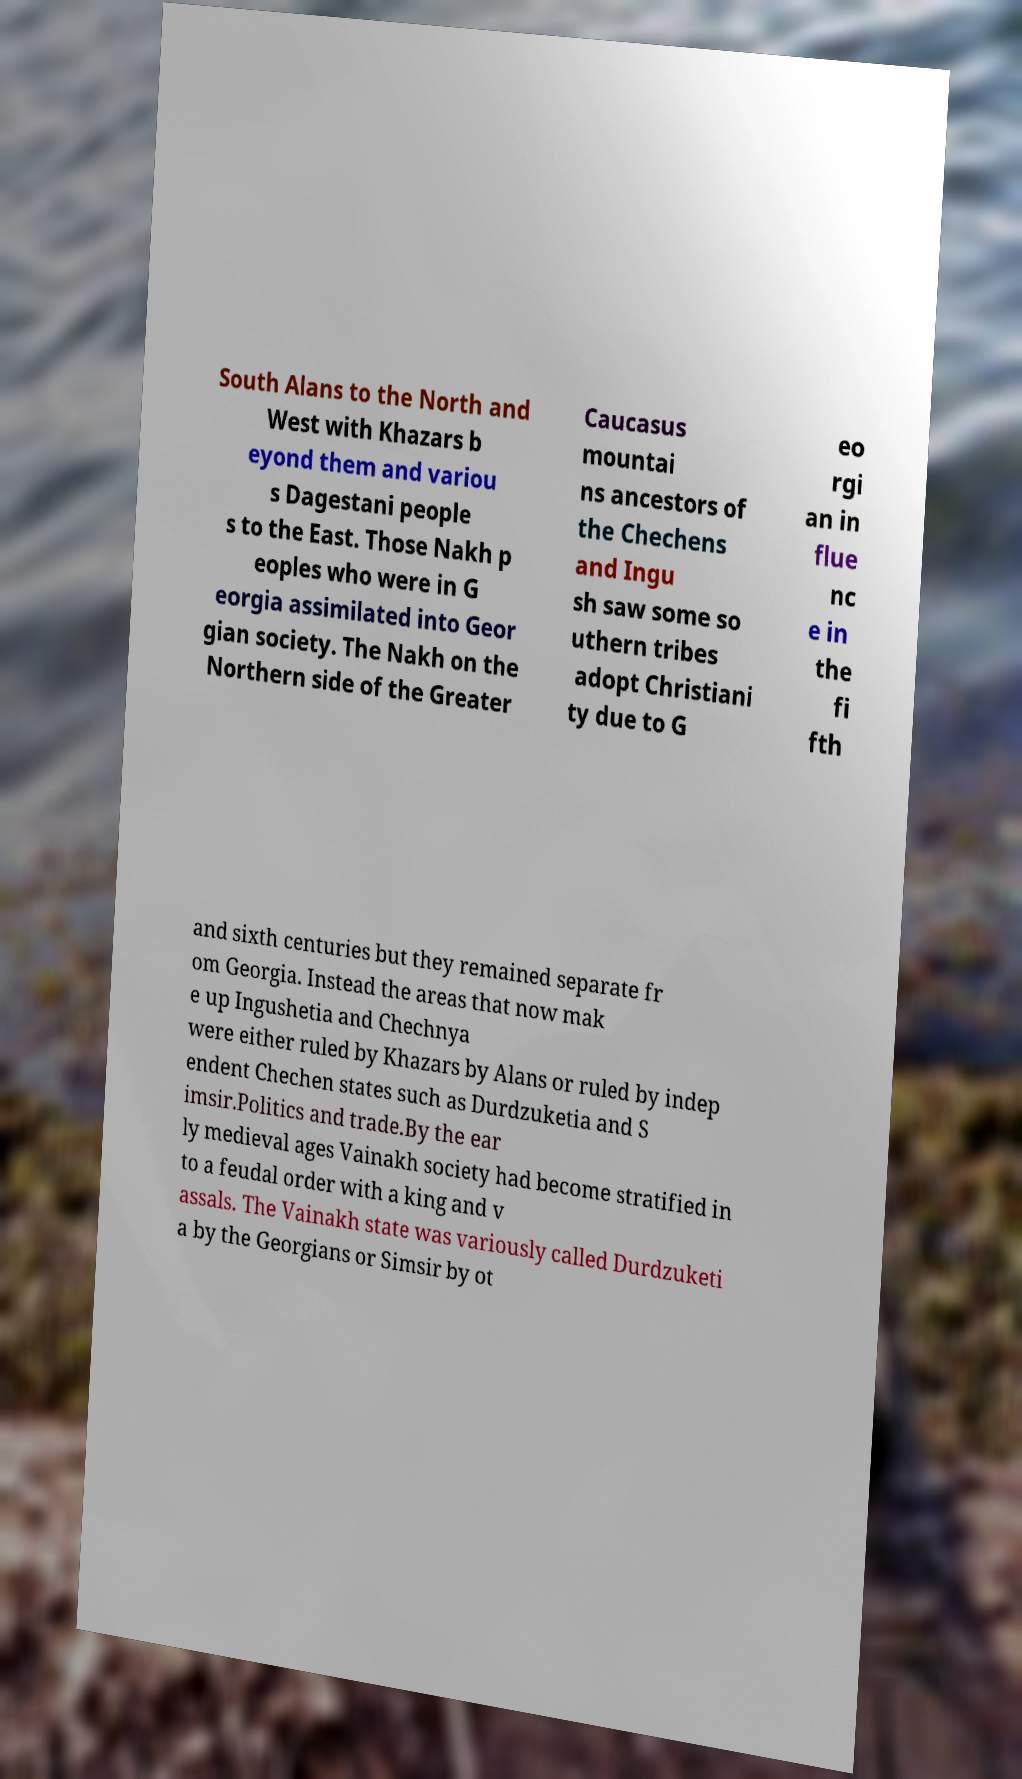Can you accurately transcribe the text from the provided image for me? South Alans to the North and West with Khazars b eyond them and variou s Dagestani people s to the East. Those Nakh p eoples who were in G eorgia assimilated into Geor gian society. The Nakh on the Northern side of the Greater Caucasus mountai ns ancestors of the Chechens and Ingu sh saw some so uthern tribes adopt Christiani ty due to G eo rgi an in flue nc e in the fi fth and sixth centuries but they remained separate fr om Georgia. Instead the areas that now mak e up Ingushetia and Chechnya were either ruled by Khazars by Alans or ruled by indep endent Chechen states such as Durdzuketia and S imsir.Politics and trade.By the ear ly medieval ages Vainakh society had become stratified in to a feudal order with a king and v assals. The Vainakh state was variously called Durdzuketi a by the Georgians or Simsir by ot 